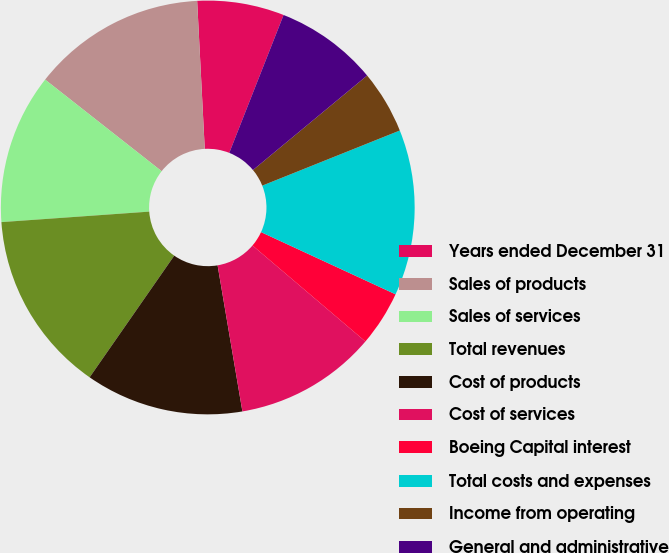Convert chart to OTSL. <chart><loc_0><loc_0><loc_500><loc_500><pie_chart><fcel>Years ended December 31<fcel>Sales of products<fcel>Sales of services<fcel>Total revenues<fcel>Cost of products<fcel>Cost of services<fcel>Boeing Capital interest<fcel>Total costs and expenses<fcel>Income from operating<fcel>General and administrative<nl><fcel>6.79%<fcel>13.58%<fcel>11.73%<fcel>14.2%<fcel>12.35%<fcel>11.11%<fcel>4.32%<fcel>12.96%<fcel>4.94%<fcel>8.02%<nl></chart> 